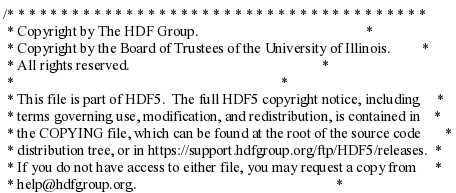Convert code to text. <code><loc_0><loc_0><loc_500><loc_500><_C_>/* * * * * * * * * * * * * * * * * * * * * * * * * * * * * * * * * * * * * * *
 * Copyright by The HDF Group.                                               *
 * Copyright by the Board of Trustees of the University of Illinois.         *
 * All rights reserved.                                                      *
 *                                                                           *
 * This file is part of HDF5.  The full HDF5 copyright notice, including     *
 * terms governing use, modification, and redistribution, is contained in    *
 * the COPYING file, which can be found at the root of the source code       *
 * distribution tree, or in https://support.hdfgroup.org/ftp/HDF5/releases.  *
 * If you do not have access to either file, you may request a copy from     *
 * help@hdfgroup.org.                                                        *</code> 